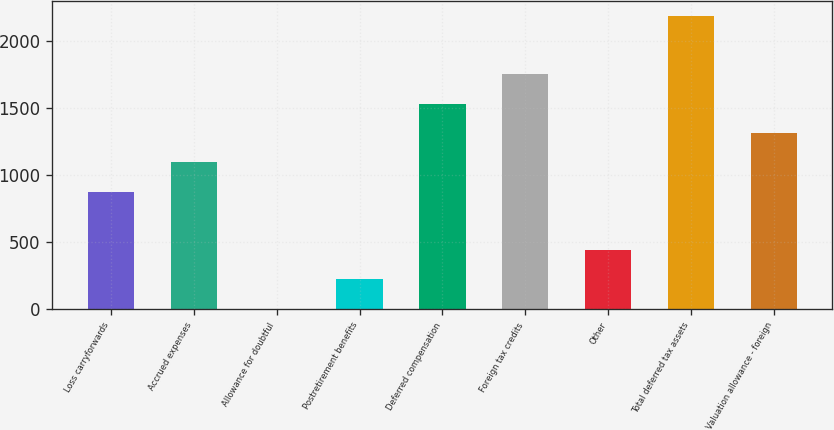Convert chart to OTSL. <chart><loc_0><loc_0><loc_500><loc_500><bar_chart><fcel>Loss carryforwards<fcel>Accrued expenses<fcel>Allowance for doubtful<fcel>Postretirement benefits<fcel>Deferred compensation<fcel>Foreign tax credits<fcel>Other<fcel>Total deferred tax assets<fcel>Valuation allowance - foreign<nl><fcel>876<fcel>1094<fcel>4<fcel>222<fcel>1530<fcel>1748<fcel>440<fcel>2184<fcel>1312<nl></chart> 